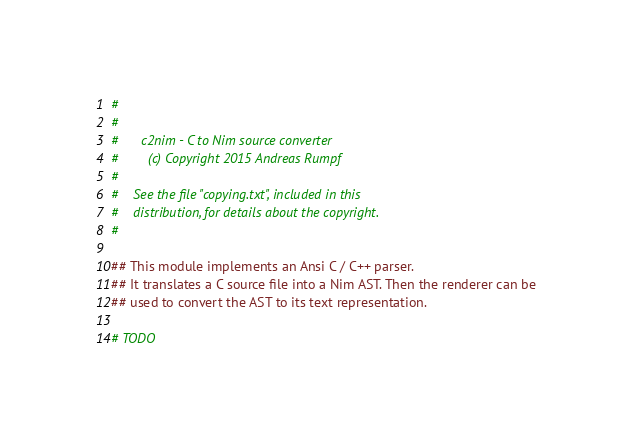<code> <loc_0><loc_0><loc_500><loc_500><_Nim_>#
#
#      c2nim - C to Nim source converter
#        (c) Copyright 2015 Andreas Rumpf
#
#    See the file "copying.txt", included in this
#    distribution, for details about the copyright.
#

## This module implements an Ansi C / C++ parser.
## It translates a C source file into a Nim AST. Then the renderer can be
## used to convert the AST to its text representation.

# TODO</code> 